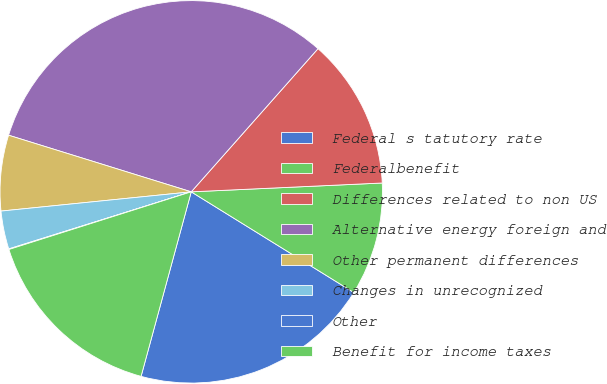<chart> <loc_0><loc_0><loc_500><loc_500><pie_chart><fcel>Federal s tatutory rate<fcel>Federalbenefit<fcel>Differences related to non US<fcel>Alternative energy foreign and<fcel>Other permanent differences<fcel>Changes in unrecognized<fcel>Other<fcel>Benefit for income taxes<nl><fcel>20.4%<fcel>9.56%<fcel>12.73%<fcel>31.75%<fcel>6.39%<fcel>3.22%<fcel>0.05%<fcel>15.9%<nl></chart> 